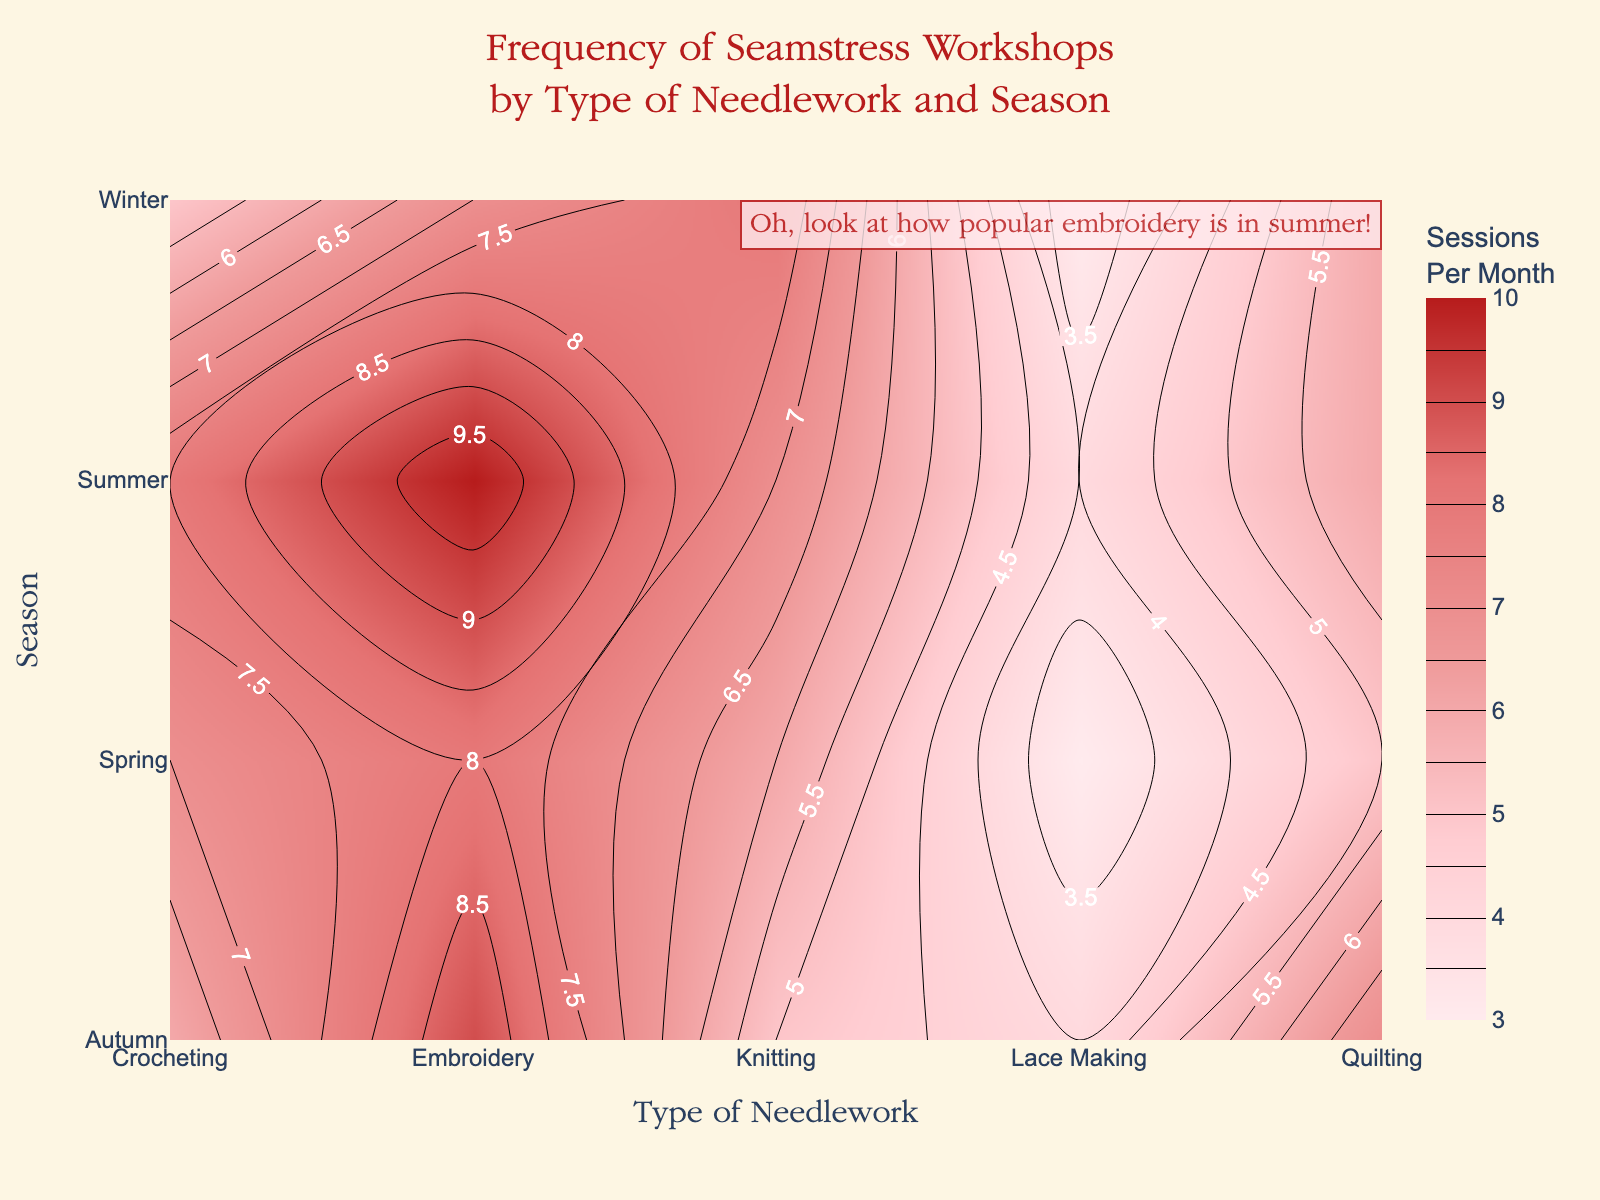what is the title of the figure? The title is located at the top of the figure and can be identified by its larger font size and central positioning. It reads, "Frequency of Seamstress Workshops by Type of Needlework and Season".
Answer: Frequency of Seamstress Workshops by Type of Needlework and Season What are the axes labels in the figure? The x-axis label at the bottom of the figure is "Type of Needlework", and the y-axis label on the left side of the figure is "Season".
Answer: Type of Needlework (x-axis); Season (y-axis) Which type of needlework associated with winter has the highest number of workshop sessions? In the winter row, the highest value for workshop sessions is located under the "Knitting" column.
Answer: Knitting How many workshop sessions are held for Lace Making in Autumn? Locate "Autumn" on the y-axis and find the corresponding value under "Lace Making" on the x-axis. The value is 4.
Answer: 4 Which seasons have more than 6 sessions each for Crocheting? Check the "Crocheting" column for values greater than 6. Both Spring and Summer seasons have 7 and 8 sessions, respectively.
Answer: Spring, Summer What's the average number of workshop sessions for Quilting across all seasons? Add the Quilting values for all seasons (5 + 6 + 7 + 6) and divide by the number of seasons (4). That gives (5+6+7+6)/4 = 24/4 = 6.
Answer: 6 In which season does Embroidery have the highest number of workshops? Look down the "Embroidery" column and find the highest value. It is 10, located in the "Summer" row.
Answer: Summer Compare the number of workshop sessions for Knitting in Spring and Autumn. Which season has more? The Spring value for Knitting is 6, and the Autumn value for Knitting is 5. Therefore, Spring has more sessions.
Answer: Spring Is the frequency of workshops higher for Crochet or Lace Making during Autumn? Compare values for Autumn in the "Crocheting" and "Lace Making" columns. Crocheting has 6 sessions, while Lace Making has 4.
Answer: Crocheting Which type of needlework has the most consistent number of workshops across all seasons? Compare all needlework types to see which has relatively stable values across seasons. "Quilting" has values of 5, 6, 7, and 6.
Answer: Quilting 